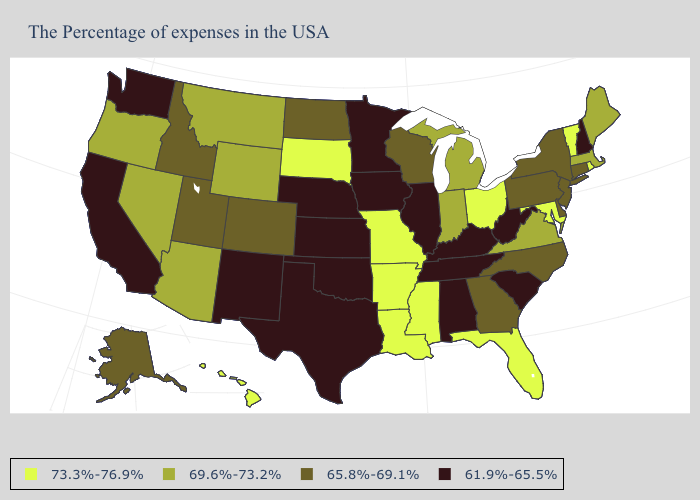What is the value of Missouri?
Be succinct. 73.3%-76.9%. Name the states that have a value in the range 73.3%-76.9%?
Be succinct. Rhode Island, Vermont, Maryland, Ohio, Florida, Mississippi, Louisiana, Missouri, Arkansas, South Dakota, Hawaii. Name the states that have a value in the range 65.8%-69.1%?
Be succinct. Connecticut, New York, New Jersey, Delaware, Pennsylvania, North Carolina, Georgia, Wisconsin, North Dakota, Colorado, Utah, Idaho, Alaska. Name the states that have a value in the range 69.6%-73.2%?
Quick response, please. Maine, Massachusetts, Virginia, Michigan, Indiana, Wyoming, Montana, Arizona, Nevada, Oregon. Which states have the highest value in the USA?
Keep it brief. Rhode Island, Vermont, Maryland, Ohio, Florida, Mississippi, Louisiana, Missouri, Arkansas, South Dakota, Hawaii. What is the highest value in the MidWest ?
Give a very brief answer. 73.3%-76.9%. Does Montana have a lower value than Ohio?
Concise answer only. Yes. What is the value of Connecticut?
Short answer required. 65.8%-69.1%. What is the value of Kansas?
Concise answer only. 61.9%-65.5%. What is the highest value in the USA?
Concise answer only. 73.3%-76.9%. What is the lowest value in states that border Oklahoma?
Write a very short answer. 61.9%-65.5%. Does the map have missing data?
Give a very brief answer. No. Among the states that border Delaware , does Maryland have the highest value?
Answer briefly. Yes. Is the legend a continuous bar?
Answer briefly. No. Name the states that have a value in the range 69.6%-73.2%?
Answer briefly. Maine, Massachusetts, Virginia, Michigan, Indiana, Wyoming, Montana, Arizona, Nevada, Oregon. 